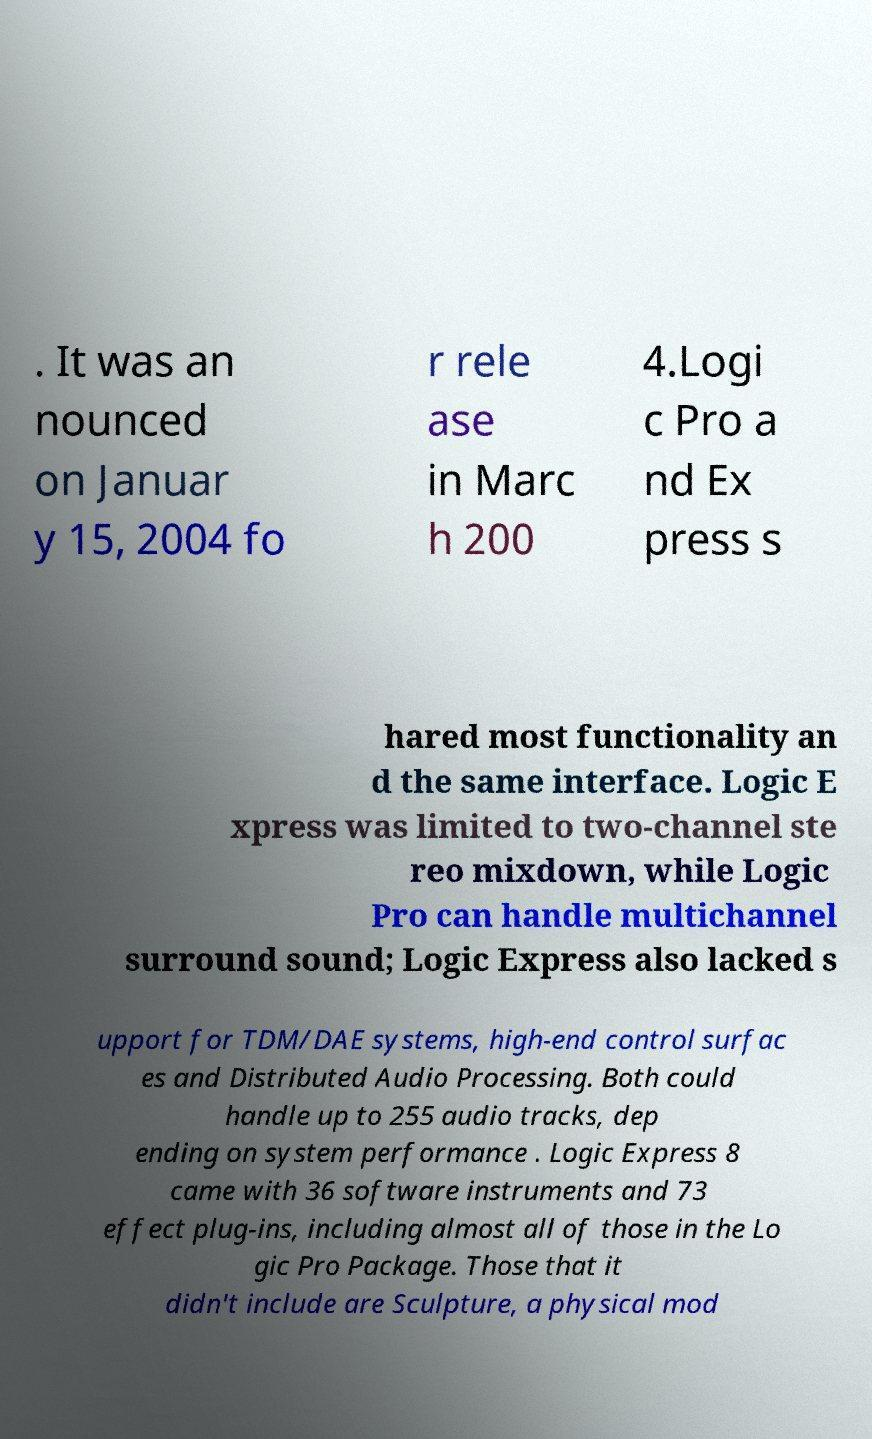Please read and relay the text visible in this image. What does it say? . It was an nounced on Januar y 15, 2004 fo r rele ase in Marc h 200 4.Logi c Pro a nd Ex press s hared most functionality an d the same interface. Logic E xpress was limited to two-channel ste reo mixdown, while Logic Pro can handle multichannel surround sound; Logic Express also lacked s upport for TDM/DAE systems, high-end control surfac es and Distributed Audio Processing. Both could handle up to 255 audio tracks, dep ending on system performance . Logic Express 8 came with 36 software instruments and 73 effect plug-ins, including almost all of those in the Lo gic Pro Package. Those that it didn't include are Sculpture, a physical mod 